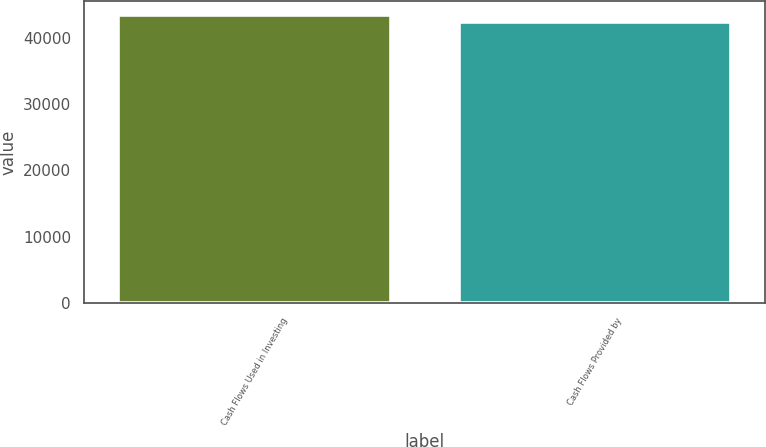Convert chart. <chart><loc_0><loc_0><loc_500><loc_500><bar_chart><fcel>Cash Flows Used in Investing<fcel>Cash Flows Provided by<nl><fcel>43324<fcel>42334<nl></chart> 